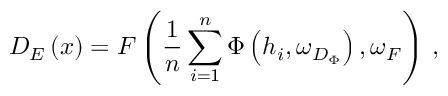Convert formula to latex. <formula><loc_0><loc_0><loc_500><loc_500>D _ { E } \left ( x \right ) = F \left ( \frac { 1 } { n } \sum _ { i = 1 } ^ { n } \Phi \left ( h _ { i } , \omega _ { D _ { \Phi } } \right ) , \omega _ { F } \right ) \, ,</formula> 